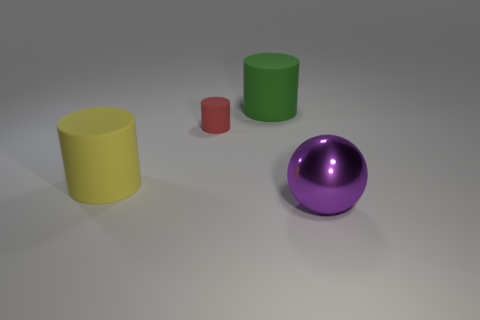Subtract all large rubber cylinders. How many cylinders are left? 1 Subtract 1 cylinders. How many cylinders are left? 2 Subtract all red cylinders. How many cylinders are left? 2 Subtract all gray cylinders. Subtract all cyan spheres. How many cylinders are left? 3 Add 4 brown rubber objects. How many objects exist? 8 Subtract all cylinders. How many objects are left? 1 Subtract all gray shiny cylinders. Subtract all large rubber cylinders. How many objects are left? 2 Add 1 large things. How many large things are left? 4 Add 2 red spheres. How many red spheres exist? 2 Subtract 1 purple spheres. How many objects are left? 3 